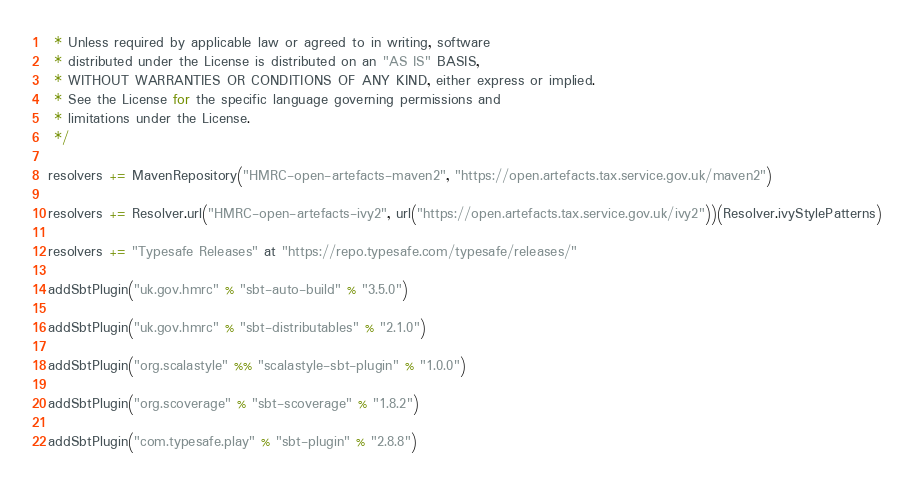<code> <loc_0><loc_0><loc_500><loc_500><_Scala_> * Unless required by applicable law or agreed to in writing, software
 * distributed under the License is distributed on an "AS IS" BASIS,
 * WITHOUT WARRANTIES OR CONDITIONS OF ANY KIND, either express or implied.
 * See the License for the specific language governing permissions and
 * limitations under the License.
 */

resolvers += MavenRepository("HMRC-open-artefacts-maven2", "https://open.artefacts.tax.service.gov.uk/maven2")

resolvers += Resolver.url("HMRC-open-artefacts-ivy2", url("https://open.artefacts.tax.service.gov.uk/ivy2"))(Resolver.ivyStylePatterns)

resolvers += "Typesafe Releases" at "https://repo.typesafe.com/typesafe/releases/"

addSbtPlugin("uk.gov.hmrc" % "sbt-auto-build" % "3.5.0")

addSbtPlugin("uk.gov.hmrc" % "sbt-distributables" % "2.1.0")

addSbtPlugin("org.scalastyle" %% "scalastyle-sbt-plugin" % "1.0.0")

addSbtPlugin("org.scoverage" % "sbt-scoverage" % "1.8.2")

addSbtPlugin("com.typesafe.play" % "sbt-plugin" % "2.8.8")
</code> 